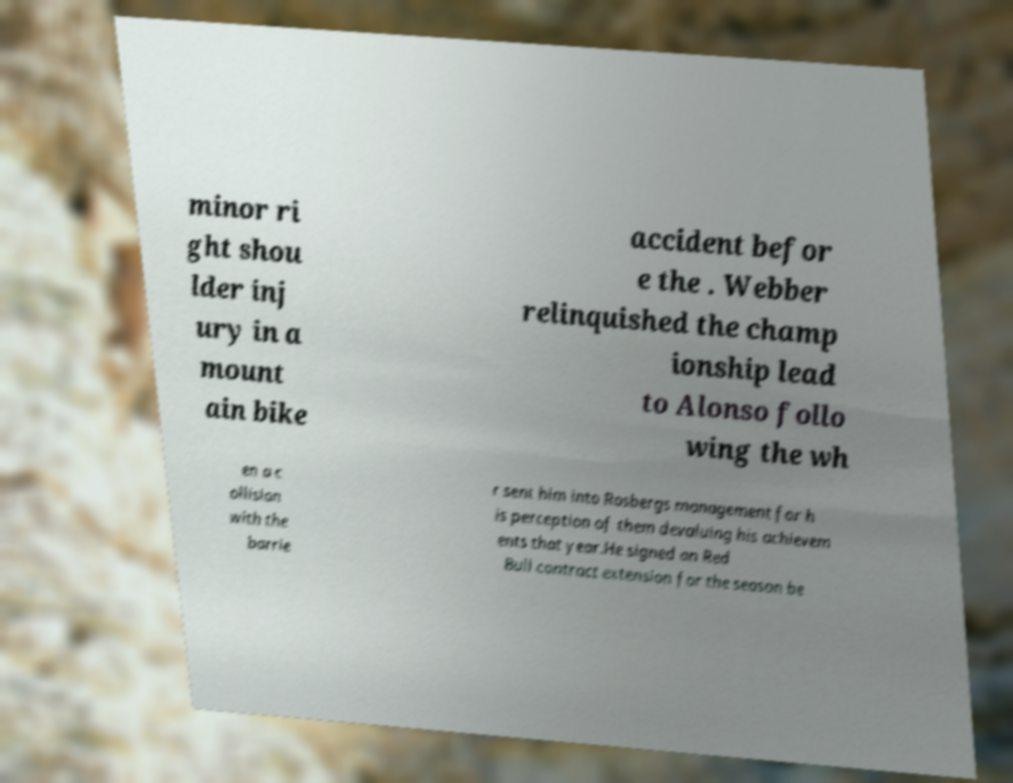What messages or text are displayed in this image? I need them in a readable, typed format. minor ri ght shou lder inj ury in a mount ain bike accident befor e the . Webber relinquished the champ ionship lead to Alonso follo wing the wh en a c ollision with the barrie r sent him into Rosbergs management for h is perception of them devaluing his achievem ents that year.He signed an Red Bull contract extension for the season be 